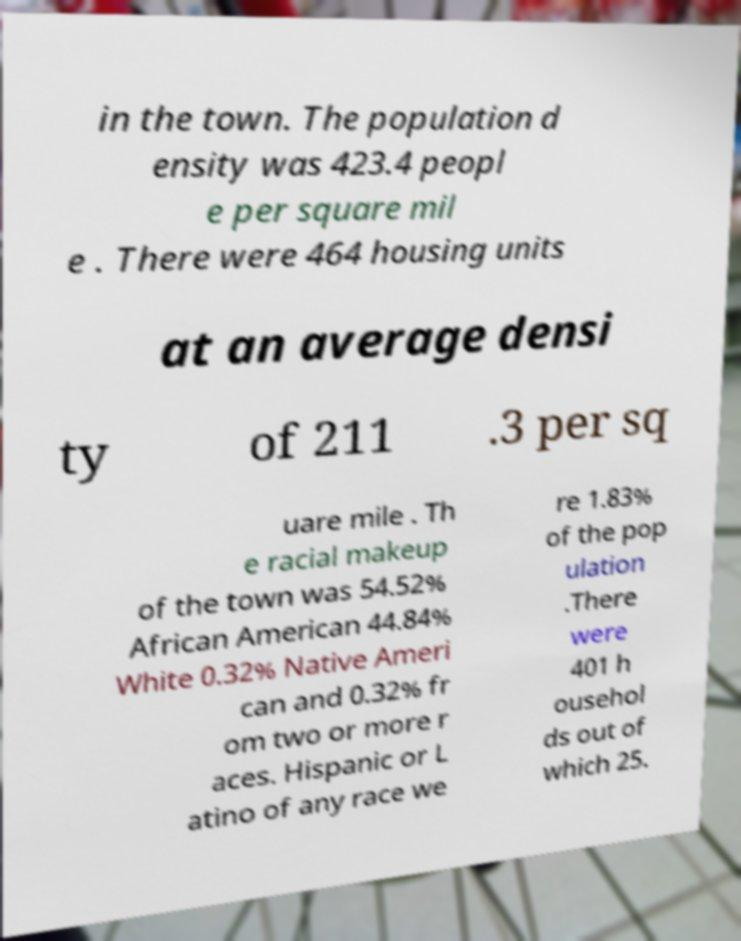Please read and relay the text visible in this image. What does it say? in the town. The population d ensity was 423.4 peopl e per square mil e . There were 464 housing units at an average densi ty of 211 .3 per sq uare mile . Th e racial makeup of the town was 54.52% African American 44.84% White 0.32% Native Ameri can and 0.32% fr om two or more r aces. Hispanic or L atino of any race we re 1.83% of the pop ulation .There were 401 h ousehol ds out of which 25. 